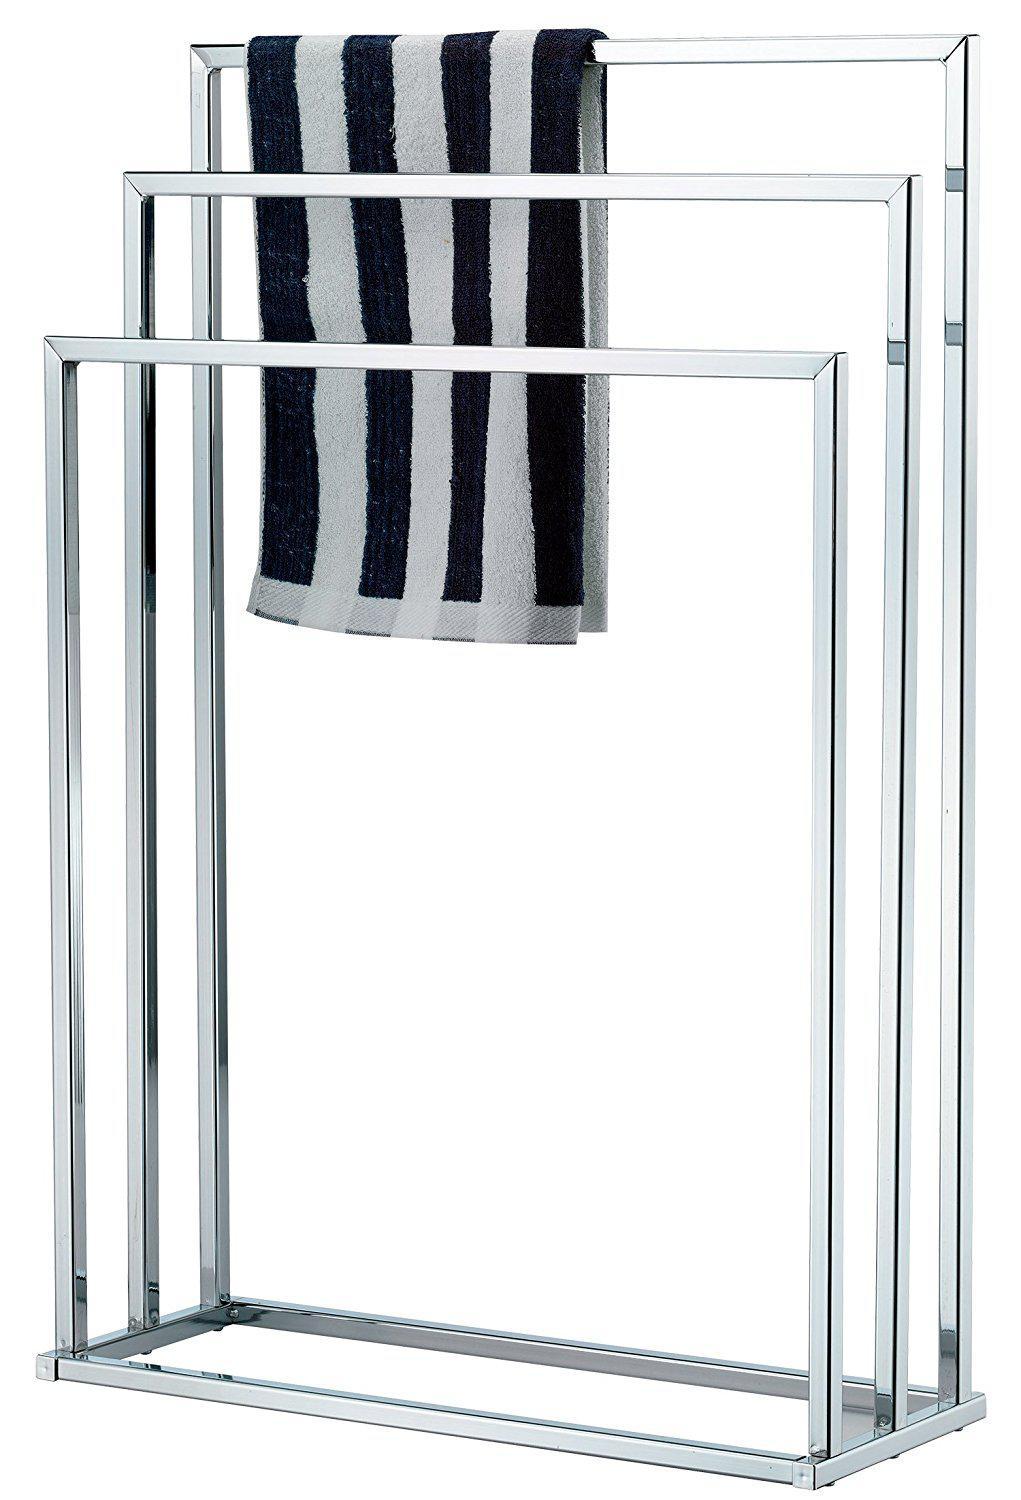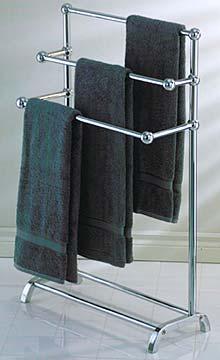The first image is the image on the left, the second image is the image on the right. Considering the images on both sides, is "One set of towels is plain, and the other has a pattern on at least a portion of it." valid? Answer yes or no. Yes. 